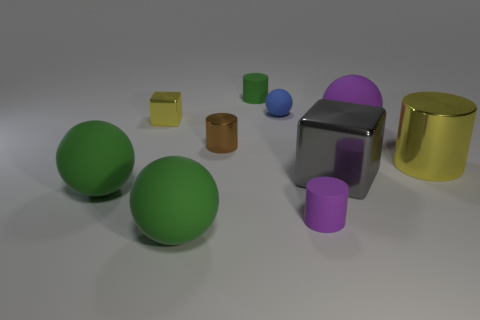Subtract all brown balls. Subtract all purple blocks. How many balls are left? 4 Subtract all balls. How many objects are left? 6 Subtract all big blue cylinders. Subtract all large shiny things. How many objects are left? 8 Add 8 green rubber spheres. How many green rubber spheres are left? 10 Add 6 tiny matte spheres. How many tiny matte spheres exist? 7 Subtract 0 cyan cylinders. How many objects are left? 10 